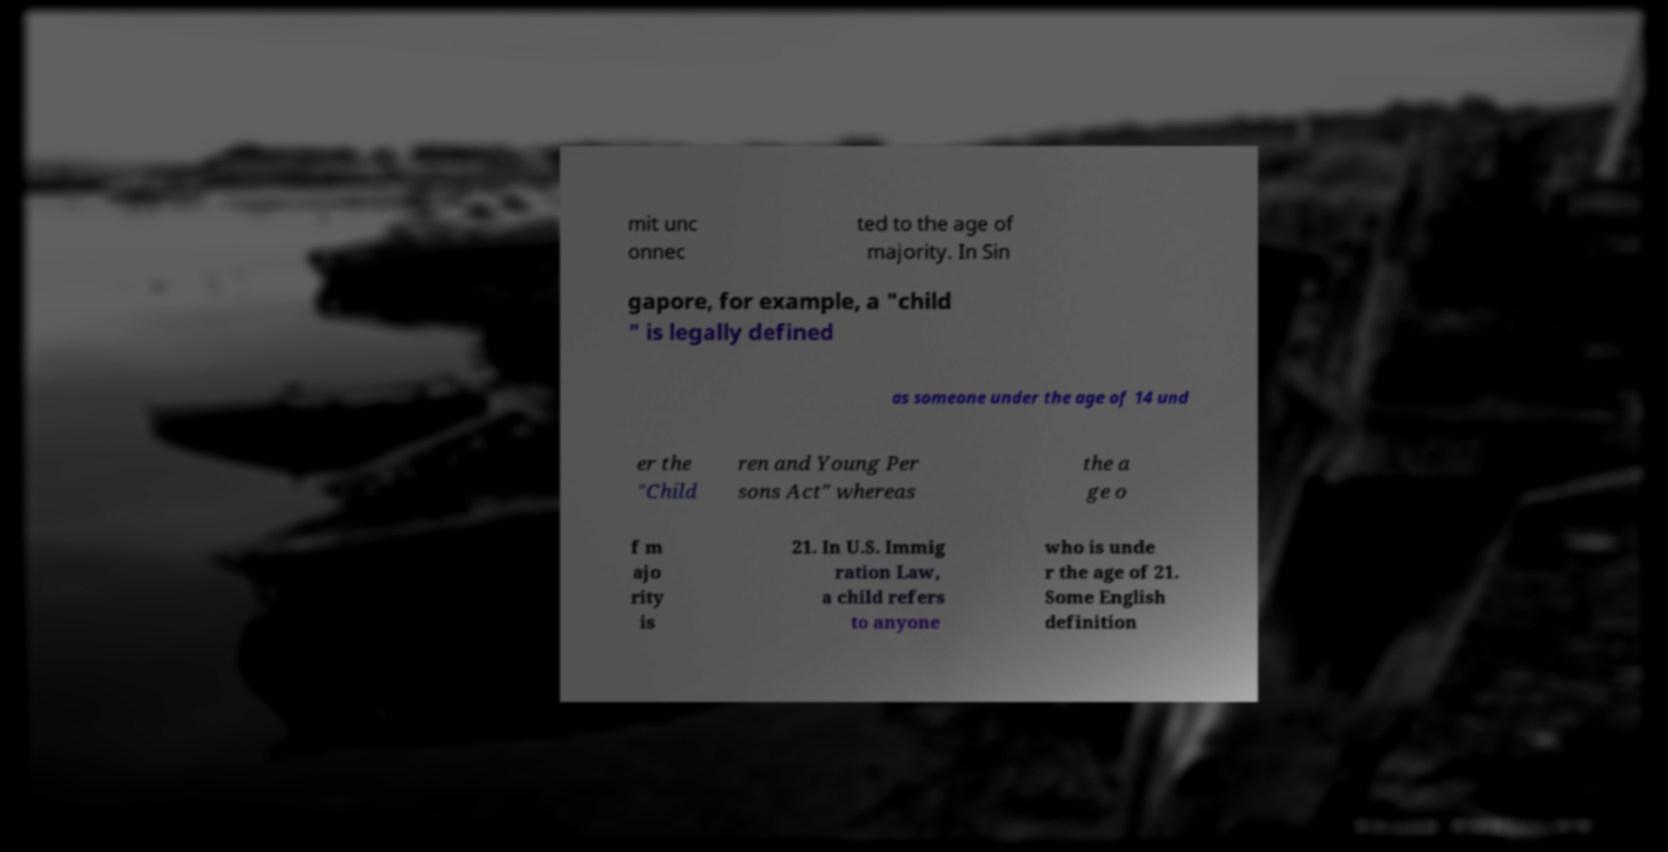Could you extract and type out the text from this image? mit unc onnec ted to the age of majority. In Sin gapore, for example, a "child " is legally defined as someone under the age of 14 und er the "Child ren and Young Per sons Act" whereas the a ge o f m ajo rity is 21. In U.S. Immig ration Law, a child refers to anyone who is unde r the age of 21. Some English definition 